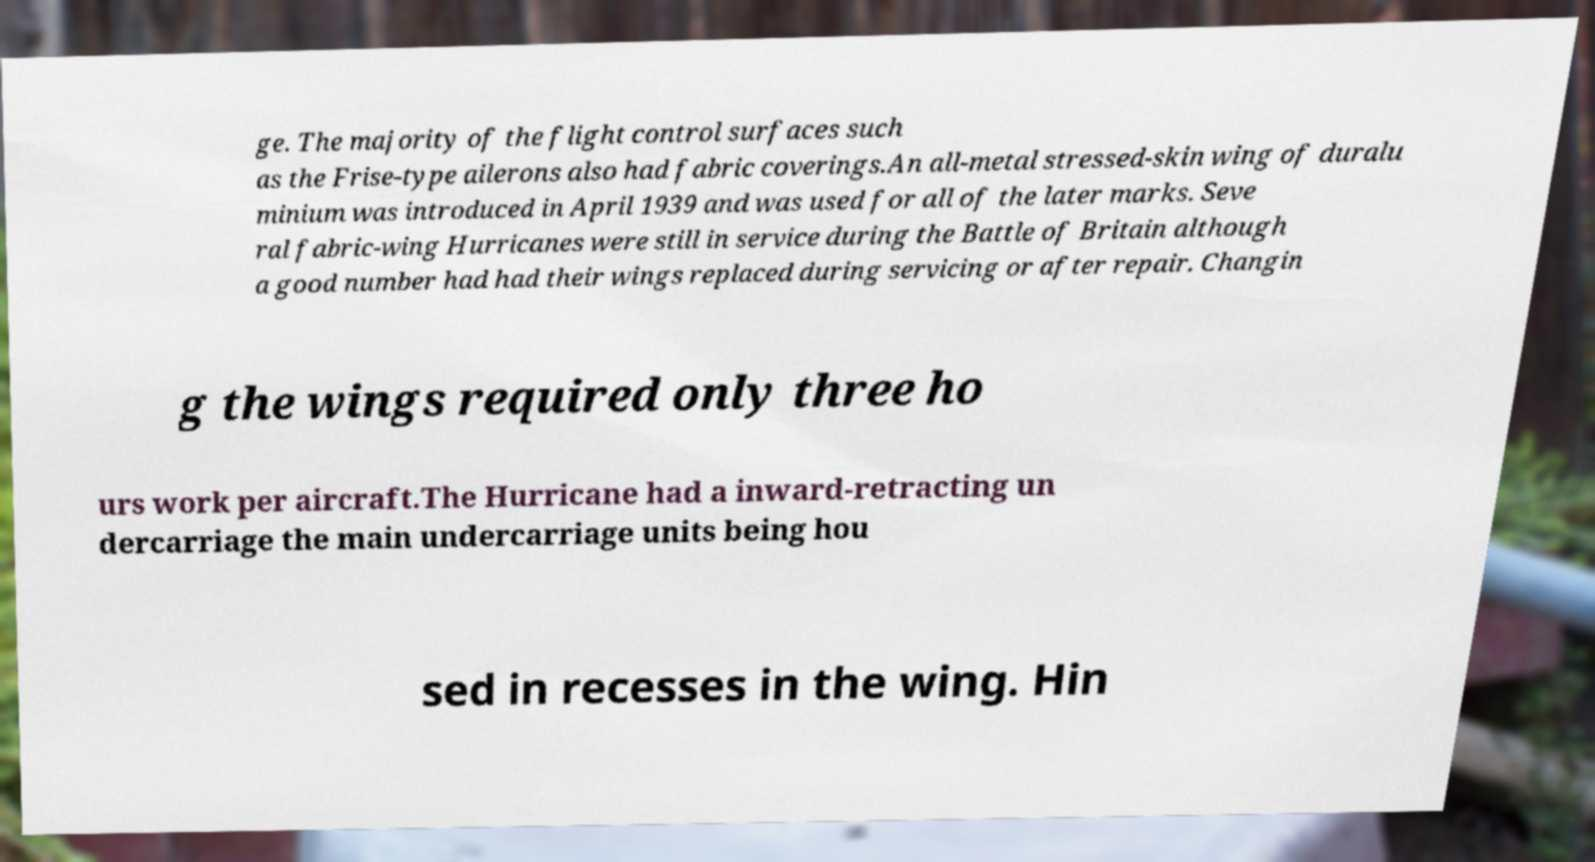For documentation purposes, I need the text within this image transcribed. Could you provide that? ge. The majority of the flight control surfaces such as the Frise-type ailerons also had fabric coverings.An all-metal stressed-skin wing of duralu minium was introduced in April 1939 and was used for all of the later marks. Seve ral fabric-wing Hurricanes were still in service during the Battle of Britain although a good number had had their wings replaced during servicing or after repair. Changin g the wings required only three ho urs work per aircraft.The Hurricane had a inward-retracting un dercarriage the main undercarriage units being hou sed in recesses in the wing. Hin 